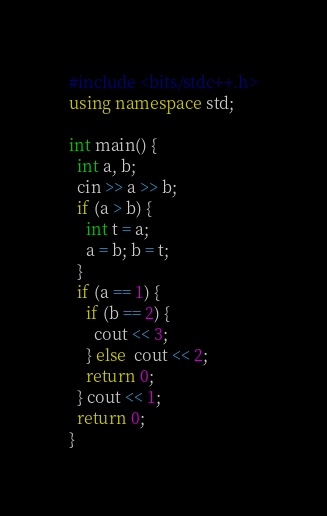Convert code to text. <code><loc_0><loc_0><loc_500><loc_500><_C++_>#include <bits/stdc++.h>
using namespace std;

int main() {
  int a, b;
  cin >> a >> b;
  if (a > b) {
    int t = a;
    a = b; b = t;
  }
  if (a == 1) {
    if (b == 2) {
      cout << 3;
    } else  cout << 2;
    return 0;
  } cout << 1;
  return 0;
}
</code> 